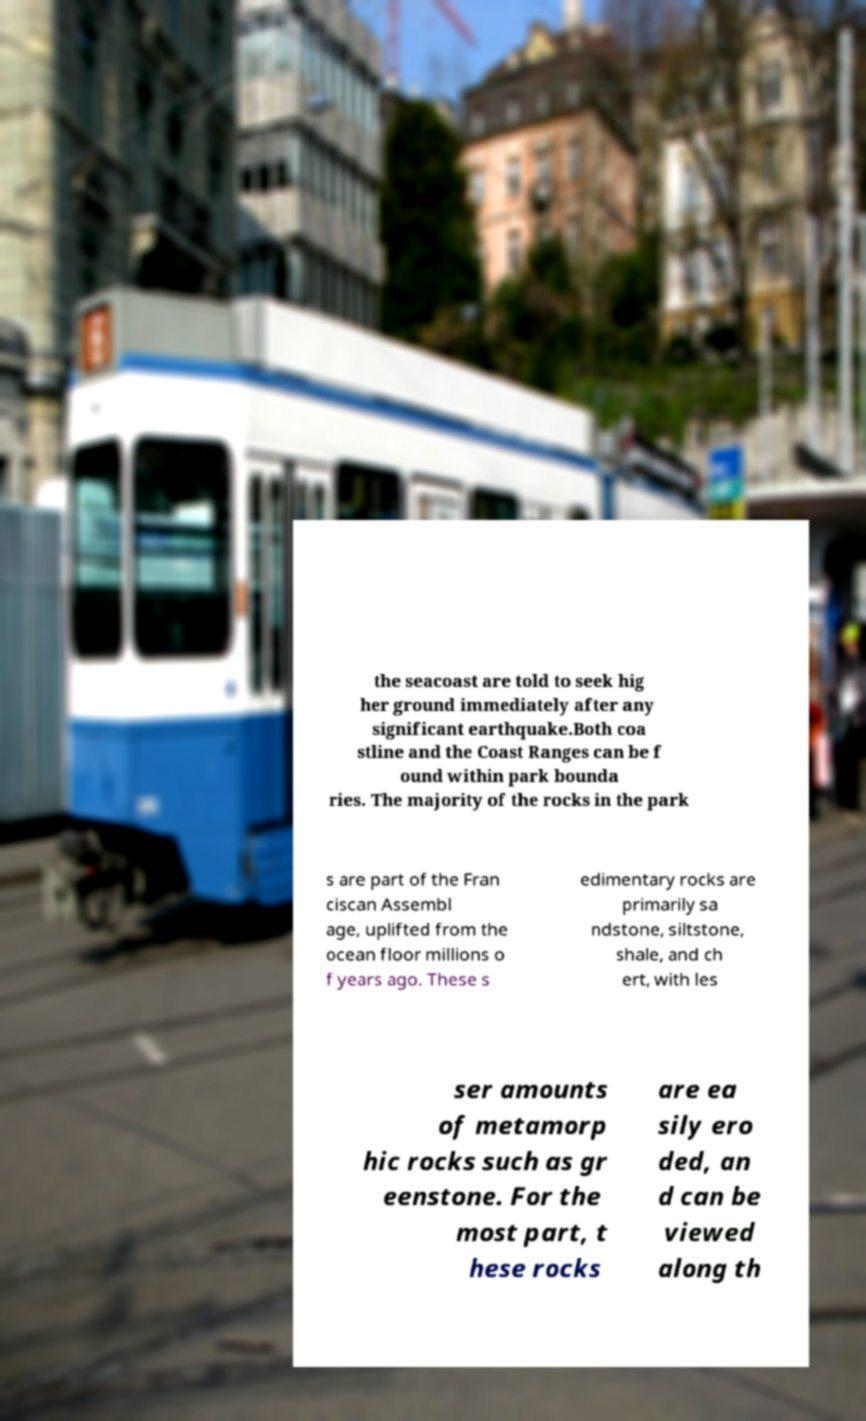Can you read and provide the text displayed in the image?This photo seems to have some interesting text. Can you extract and type it out for me? the seacoast are told to seek hig her ground immediately after any significant earthquake.Both coa stline and the Coast Ranges can be f ound within park bounda ries. The majority of the rocks in the park s are part of the Fran ciscan Assembl age, uplifted from the ocean floor millions o f years ago. These s edimentary rocks are primarily sa ndstone, siltstone, shale, and ch ert, with les ser amounts of metamorp hic rocks such as gr eenstone. For the most part, t hese rocks are ea sily ero ded, an d can be viewed along th 